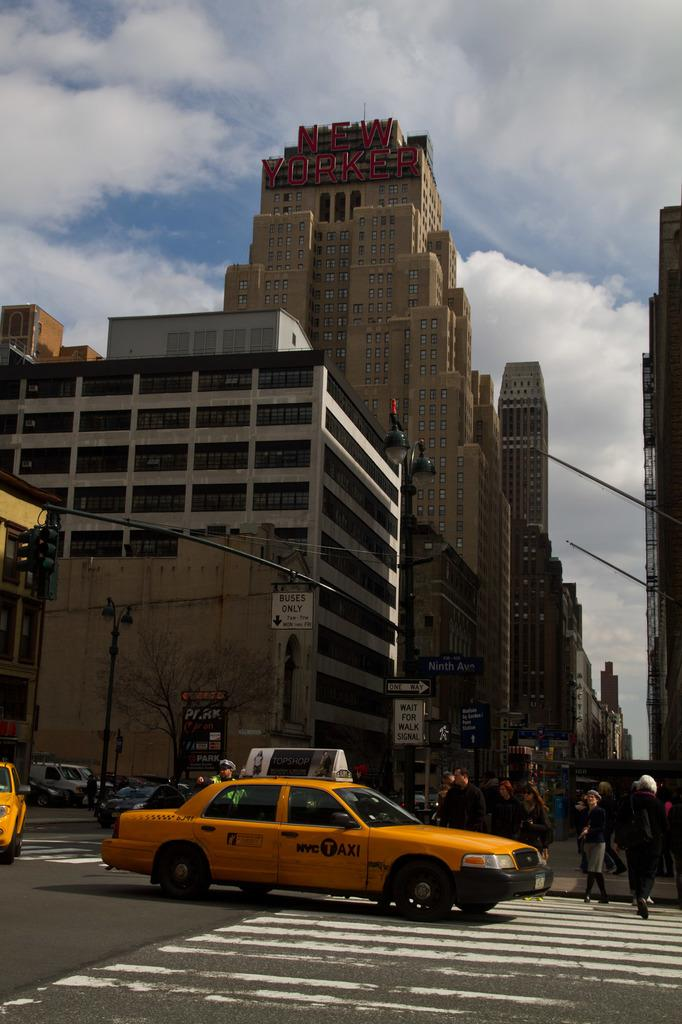<image>
Render a clear and concise summary of the photo. A city street scene where the tallest building says New Yorker. 